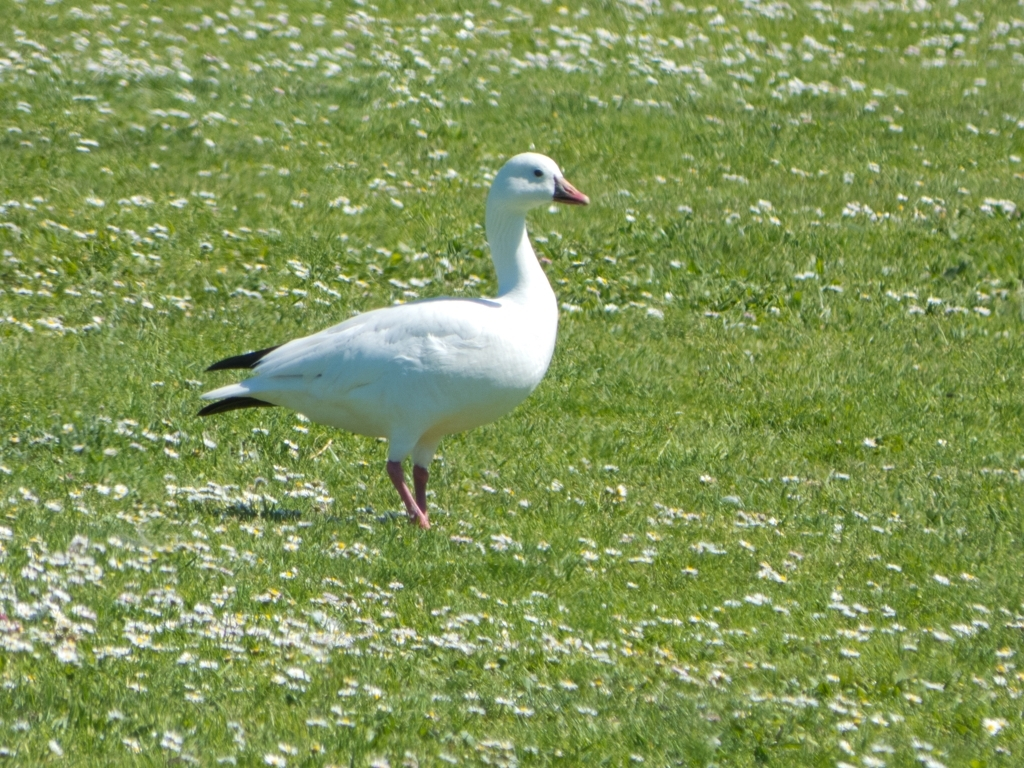Can you tell me what species the bird in the image might be? While I can't make definitive statements about species, the bird in the image resembles a Ross's Goose, characterized by its relatively small size, round head, stubby bill, and white plumage with black wingtips. Is this bird common in any particular region? The Ross's Goose is typically found in North America, breeding in northern Canada and wintering mostly in the southern United States and Mexico. Their habitat often includes marshes, prairies, and wetlands during migration. 